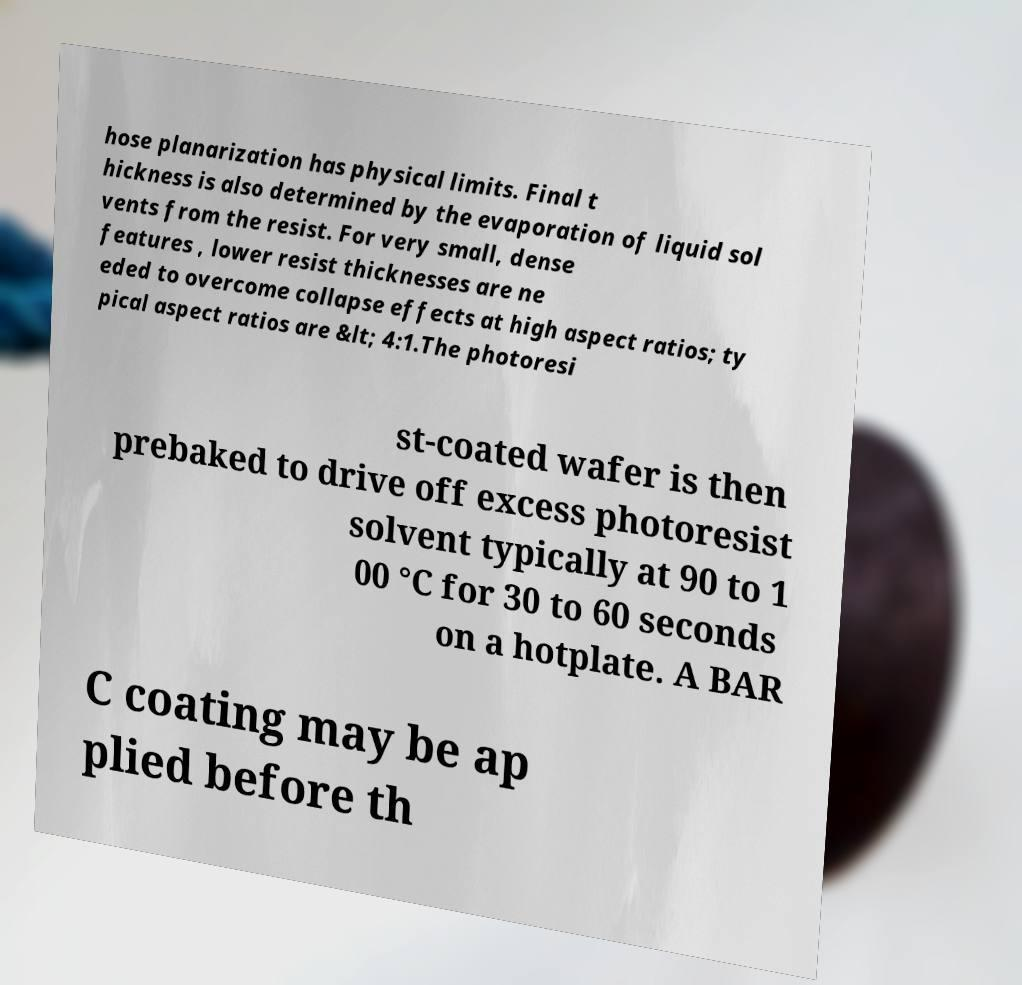Please identify and transcribe the text found in this image. hose planarization has physical limits. Final t hickness is also determined by the evaporation of liquid sol vents from the resist. For very small, dense features , lower resist thicknesses are ne eded to overcome collapse effects at high aspect ratios; ty pical aspect ratios are &lt; 4:1.The photoresi st-coated wafer is then prebaked to drive off excess photoresist solvent typically at 90 to 1 00 °C for 30 to 60 seconds on a hotplate. A BAR C coating may be ap plied before th 